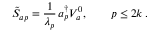<formula> <loc_0><loc_0><loc_500><loc_500>\tilde { S } _ { a p } = { \frac { 1 } { \lambda _ { p } } } \, a _ { p } ^ { \dagger } V _ { a } ^ { 0 } , \quad p \leq 2 k \, .</formula> 